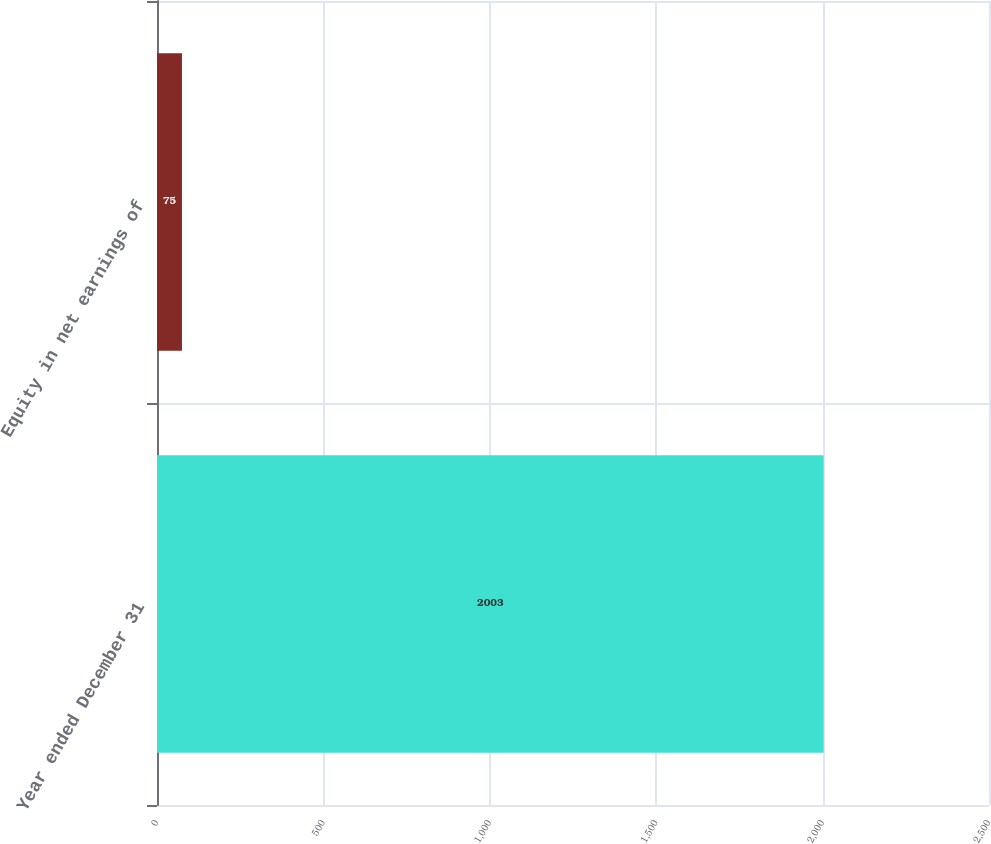Convert chart. <chart><loc_0><loc_0><loc_500><loc_500><bar_chart><fcel>Year ended December 31<fcel>Equity in net earnings of<nl><fcel>2003<fcel>75<nl></chart> 